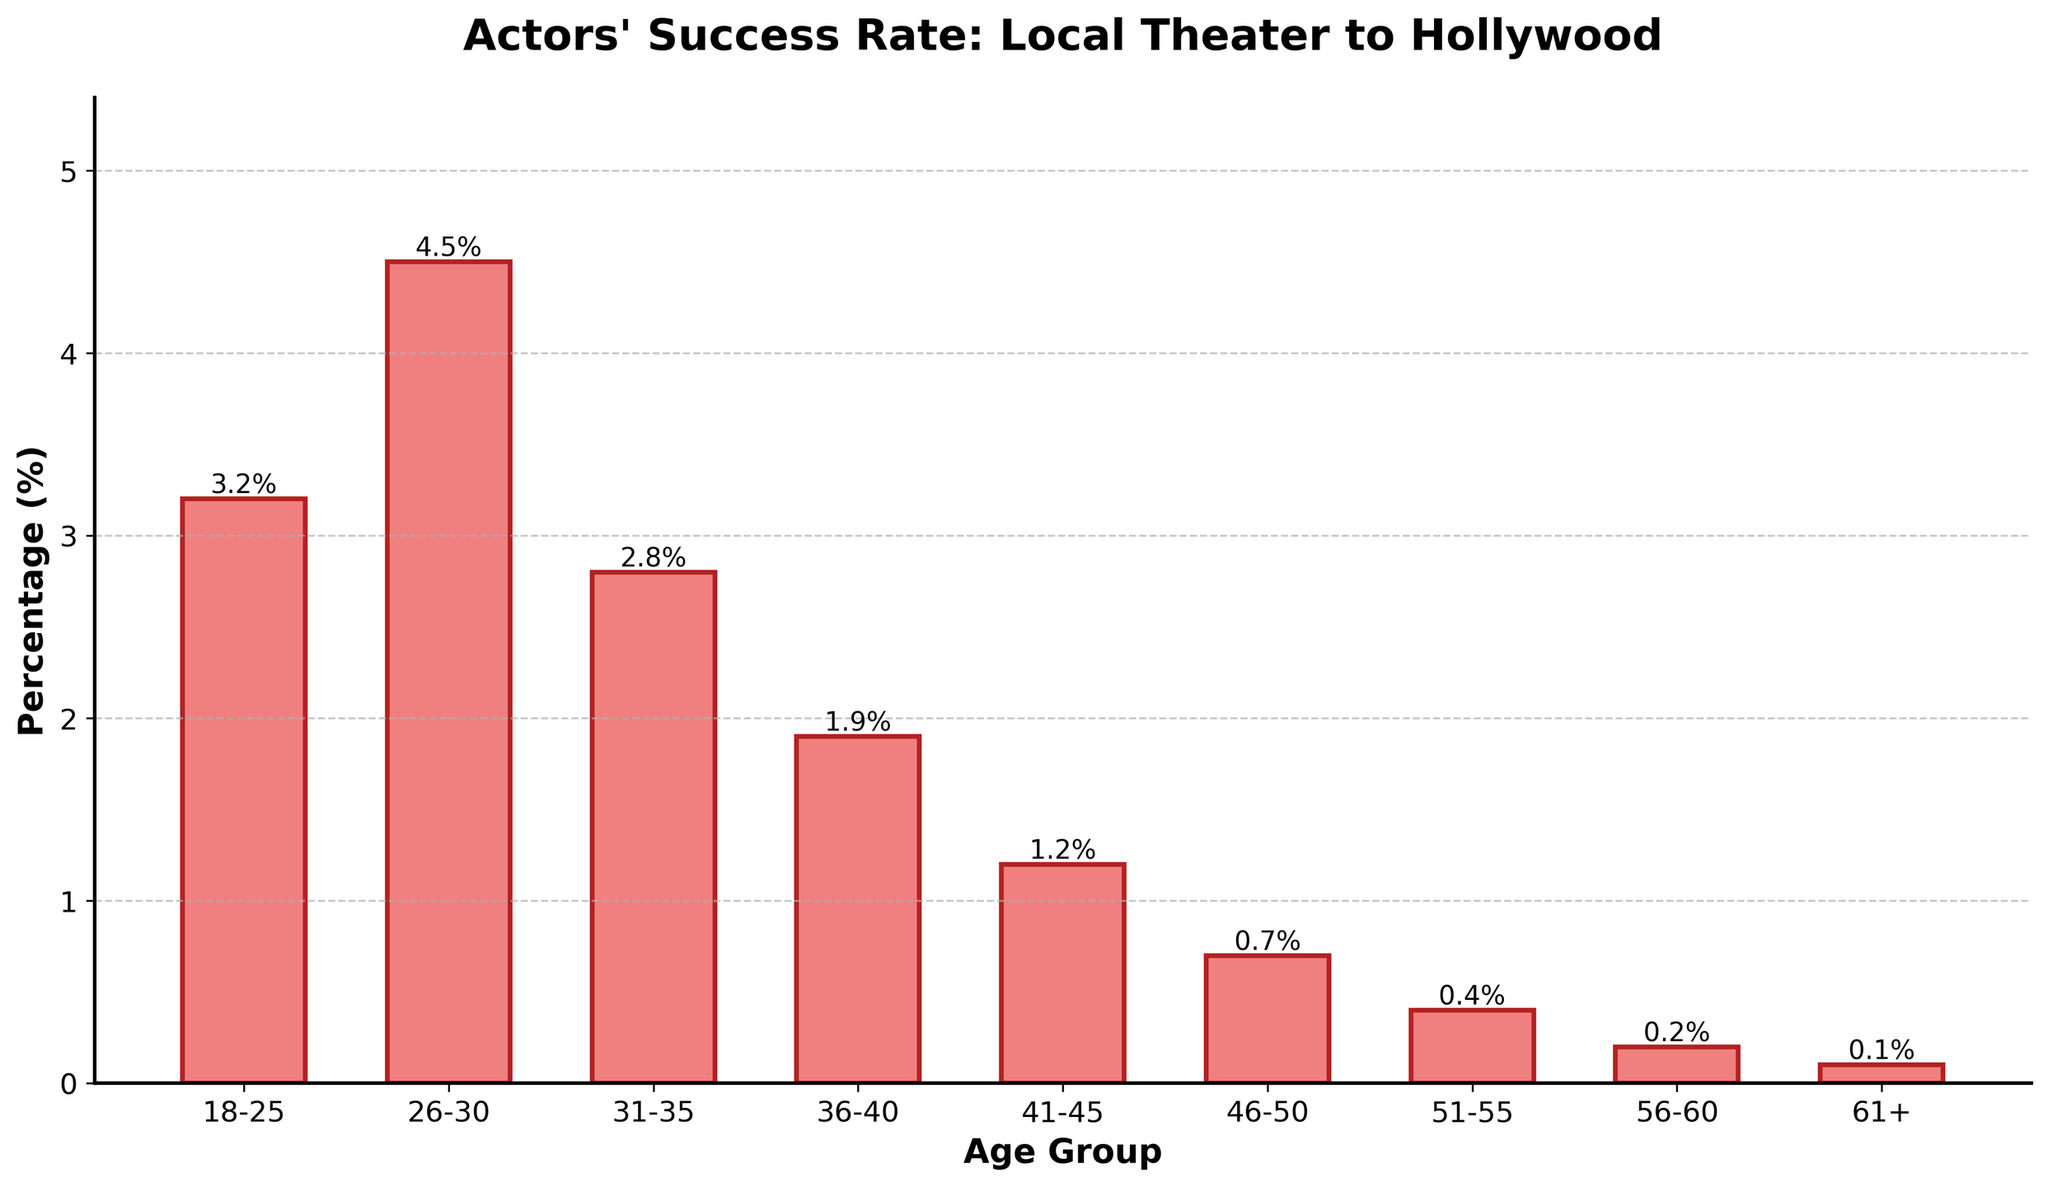What is the age group with the highest percentage of successful transitions from local theater to Hollywood? The highest bar in the chart represents the age group 26-30, which has the highest success rate.
Answer: 26-30 Which age group has the lowest success rate? The smallest bar represents the age group 61+, indicating the lowest success rate.
Answer: 61+ How much higher is the success rate of the 26-30 age group compared to the 31-35 age group? The success rate of the 26-30 age group is 4.5%, and the success rate of the 31-35 age group is 2.8%. The difference is 4.5% - 2.8% = 1.7%.
Answer: 1.7% What is the combined success rate of actors aged between 18-25 and 26-30? The success rates for 18-25 is 3.2% and for 26-30 is 4.5%. Adding them gives 3.2% + 4.5% = 7.7%.
Answer: 7.7% What is the average success rate of all age groups? Sum all percentages (3.2 + 4.5 + 2.8 + 1.9 + 1.2 + 0.7 + 0.4 + 0.2 + 0.1) = 15%, and divide by the number of age groups, which is 9. So, the average success rate is 15 / 9 ≈ 1.67%.
Answer: 1.67% What percentage of successful transitions are achieved by actors aged 41-45? The chart shows a 1.2% success rate for the 41-45 age group.
Answer: 1.2% Compare the success rate of actors aged 18-25 to those aged 46-50. Which group has a higher rate, and by how much? The 18-25 group has a success rate of 3.2%, while the 46-50 group has a rate of 0.7%. The difference is 3.2% - 0.7% = 2.5%. The 18-25 group has a higher rate by 2.5%.
Answer: 18-25 by 2.5% What proportion of the total success rate does the 56-60 age group represent? The success rate of the 56-60 age group is 0.2%. The total success rate is 15%. The proportion is (0.2 / 15) * 100 ≈ 1.33%.
Answer: 1.33% Identify the range of percentages demonstrated by the bars in the figure. The chart shows percentages ranging from a high of 4.5% (26-30) to a low of 0.1% (61+).
Answer: 0.1% to 4.5% Based on the visual height of the bars, which age groups have a success rate less than 1%? The bars representing the age groups 46-50, 51-55, 56-60, and 61+ are all less than 1% (0.7%, 0.4%, 0.2%, 0.1%, respectively).
Answer: 46-50, 51-55, 56-60, 61+ 